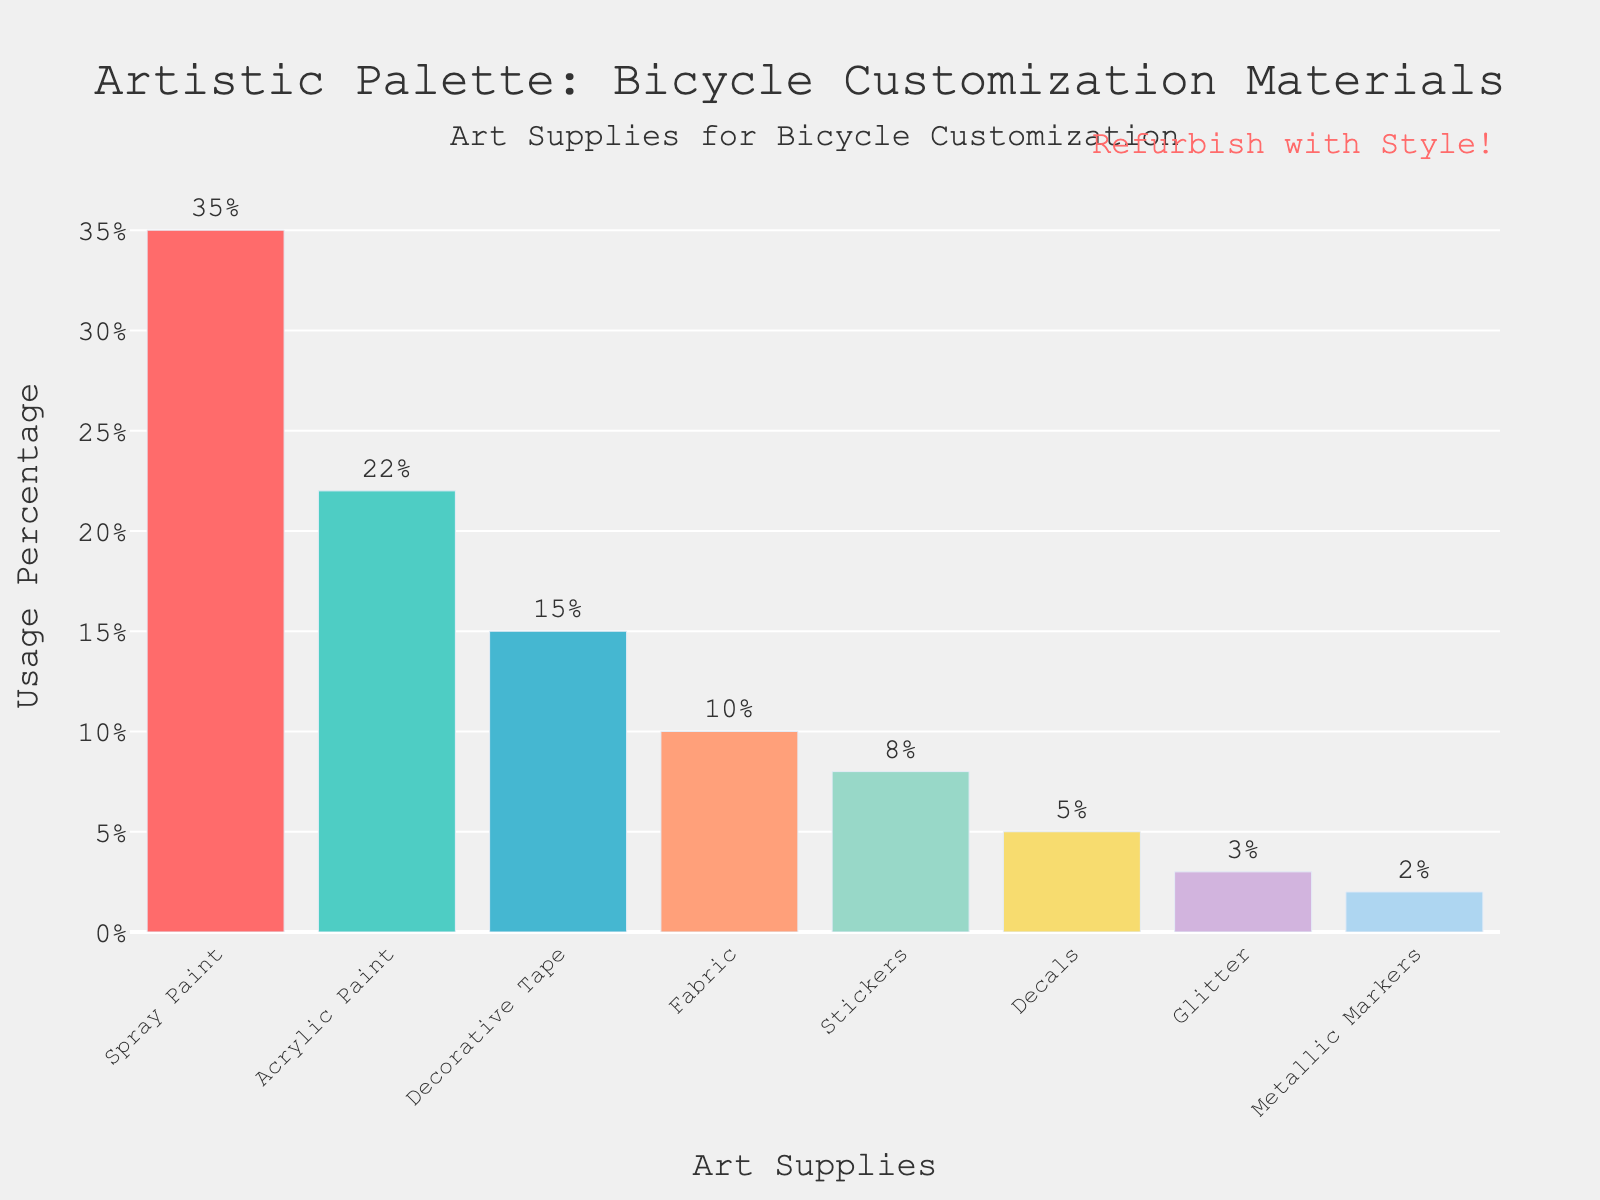What material is used the most for bicycle customization? The bar representing Spray Paint is the tallest in the chart, indicating it has the highest usage percentage.
Answer: Spray Paint What's the total percentage of usage for Stickers, Decals, and Glitter combined? Add the percentages: Stickers (8%) + Decals (5%) + Glitter (3%) = 16%.
Answer: 16% How much more percentage is Acrylic Paint used compared to Fabric? Subtract Fabric's percentage from Acrylic Paint's percentage: Acrylic Paint (22%) - Fabric (10%) = 12%.
Answer: 12% Which materials have a usage percentage under 10%? Look at the bars that extend below the 10% mark: Fabric (10%), Stickers (8%), Decals (5%), Glitter (3%), and Metallic Markers (2%).
Answer: Stickers, Decals, Glitter, Metallic Markers What's the difference in percentage usage between the most used and least used materials? Subtract the percentage of the least used material (Metallic Markers at 2%) from the most used material (Spray Paint at 35%): 35% - 2% = 33%.
Answer: 33% How does the usage of Decorative Tape compare to that of Glitter? Compare the heights of the bars: Decorative Tape is used at 15%, while Glitter is used at 3%.
Answer: Decorative Tape is used more If you sum up the usage percentages of Metallic Markers and Decals, what do you get? Add the percentages: Metallic Markers (2%) + Decals (5%) = 7%.
Answer: 7% Which color represents the Acrylic Paint bar, and what visual clue suggests this? The bar for Acrylic Paint is second from the left and is green, as indicated by the green color in the bar above the Acrylic Paint label.
Answer: Green 